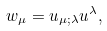<formula> <loc_0><loc_0><loc_500><loc_500>w _ { \mu } = u _ { \mu ; \lambda } u ^ { \lambda } ,</formula> 